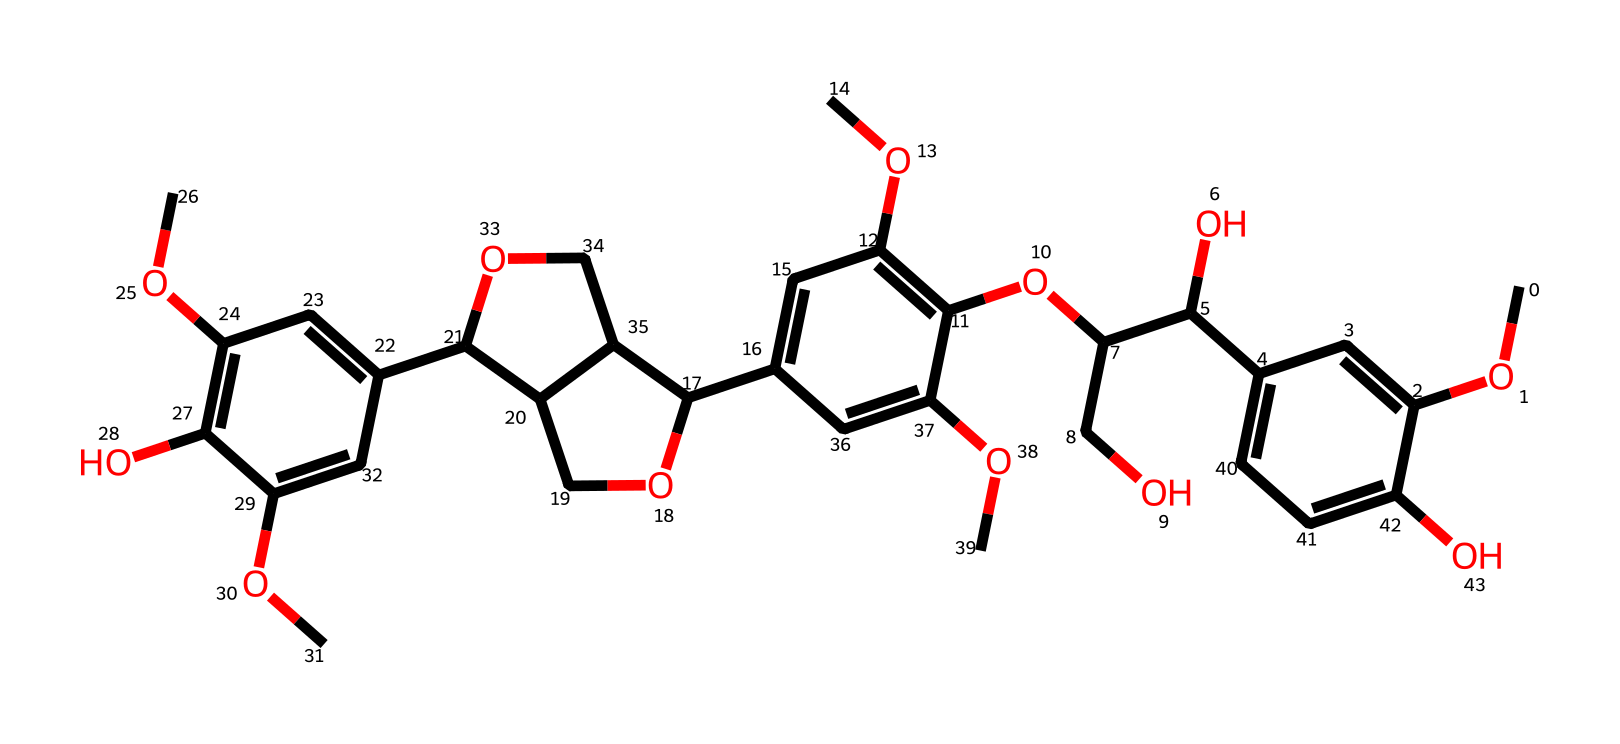How many aromatic rings are present in this compound? To determine the number of aromatic rings, I look at the structure for cyclic systems with conjugated pi electrons. In this SMILES, there are multiple 'c' denoting carbon atoms that form a cyclic structure without any 'C' indicating sp3 hybridization. Analyzing the molecule, I identify three distinct regions where the 'c' generates aromatic systems, indicating that there are three aromatic rings in total.
Answer: three What functional groups are associated with this chemical? By closely examining the SMILES representation, I can identify various functional groups. The presence of 'O' after 'C' suggests methoxy groups (–OCH3), while 'C(O)' indicates that hydroxyl groups (–OH) are present. Since both are identified alongside the aromatic rings, I can list the prevalent functional groups as methoxy and hydroxyl.
Answer: methoxy and hydroxyl What is the molecular formula derived from this compound? To derive the molecular formula, I count the number of carbon (C), hydrogen (H), and oxygen (O) atoms indicated in the SMILES representation. Each subgroup shows an integration of atoms with 'C' and 'O', allowing for direct counting. When compiled, the final result gives a molecular formula consistent with larger biochemicals, which is essential for calculations in chemical reactions.
Answer: C30H38O12 What type of bond is predominantly present between the carbon atoms in this structure? Analyzing the given SMILES string, I find that the majority of the bonding between carbon atoms is characterized as covalent bonds. This is because carbon typically forms four bonds with adjacent atoms. The presence of carbon connected to both aromatic and aliphatic structures demonstrates that covalent bonding is prevalent throughout the compound.
Answer: covalent What is the role of lignin in plant structures? Understanding the function of lignin requires looking into its contribution to plant anatomy. Lignin aids in the formation of woody tissues, which provide rigidity and structural support in plants. Such a compound reinforces cell walls, allowing plants to grow taller and transport water more effectively, making it integral for plant growth and sustainability.
Answer: structural support 